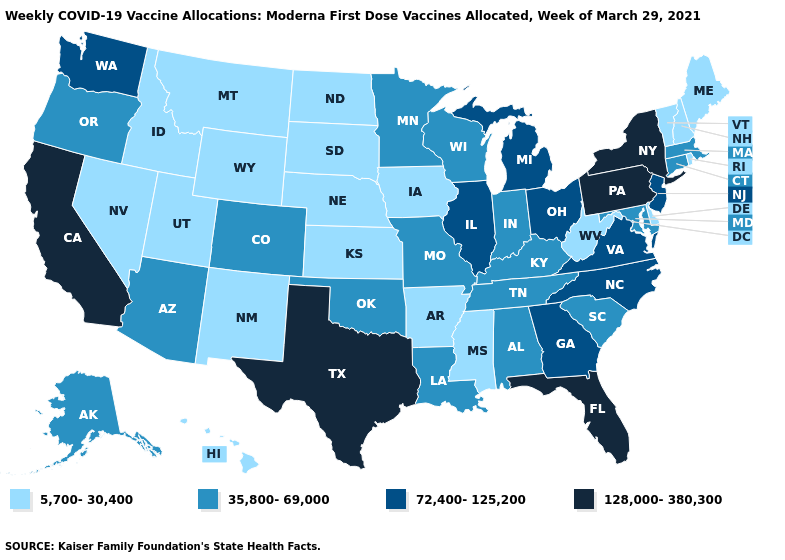Which states have the lowest value in the MidWest?
Quick response, please. Iowa, Kansas, Nebraska, North Dakota, South Dakota. Does the map have missing data?
Quick response, please. No. Name the states that have a value in the range 72,400-125,200?
Keep it brief. Georgia, Illinois, Michigan, New Jersey, North Carolina, Ohio, Virginia, Washington. Which states have the lowest value in the USA?
Quick response, please. Arkansas, Delaware, Hawaii, Idaho, Iowa, Kansas, Maine, Mississippi, Montana, Nebraska, Nevada, New Hampshire, New Mexico, North Dakota, Rhode Island, South Dakota, Utah, Vermont, West Virginia, Wyoming. What is the value of Texas?
Answer briefly. 128,000-380,300. What is the lowest value in the MidWest?
Concise answer only. 5,700-30,400. Does the first symbol in the legend represent the smallest category?
Short answer required. Yes. Among the states that border Tennessee , which have the lowest value?
Concise answer only. Arkansas, Mississippi. What is the value of Utah?
Quick response, please. 5,700-30,400. Which states have the lowest value in the USA?
Give a very brief answer. Arkansas, Delaware, Hawaii, Idaho, Iowa, Kansas, Maine, Mississippi, Montana, Nebraska, Nevada, New Hampshire, New Mexico, North Dakota, Rhode Island, South Dakota, Utah, Vermont, West Virginia, Wyoming. Name the states that have a value in the range 128,000-380,300?
Quick response, please. California, Florida, New York, Pennsylvania, Texas. Which states have the lowest value in the Northeast?
Give a very brief answer. Maine, New Hampshire, Rhode Island, Vermont. Does Massachusetts have the highest value in the Northeast?
Keep it brief. No. What is the value of Hawaii?
Quick response, please. 5,700-30,400. Name the states that have a value in the range 5,700-30,400?
Quick response, please. Arkansas, Delaware, Hawaii, Idaho, Iowa, Kansas, Maine, Mississippi, Montana, Nebraska, Nevada, New Hampshire, New Mexico, North Dakota, Rhode Island, South Dakota, Utah, Vermont, West Virginia, Wyoming. 